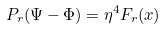Convert formula to latex. <formula><loc_0><loc_0><loc_500><loc_500>P _ { r } ( \Psi - \Phi ) = \eta ^ { 4 } F _ { r } ( x )</formula> 